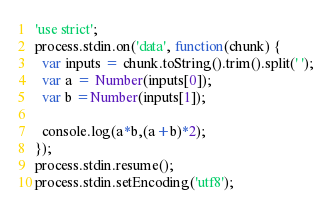<code> <loc_0><loc_0><loc_500><loc_500><_JavaScript_>'use strict';
process.stdin.on('data', function(chunk) {
  var inputs = chunk.toString().trim().split(' ');
  var a = Number(inputs[0]);
  var b =Number(inputs[1]);

  console.log(a*b,(a+b)*2);
});
process.stdin.resume();
process.stdin.setEncoding('utf8');</code> 